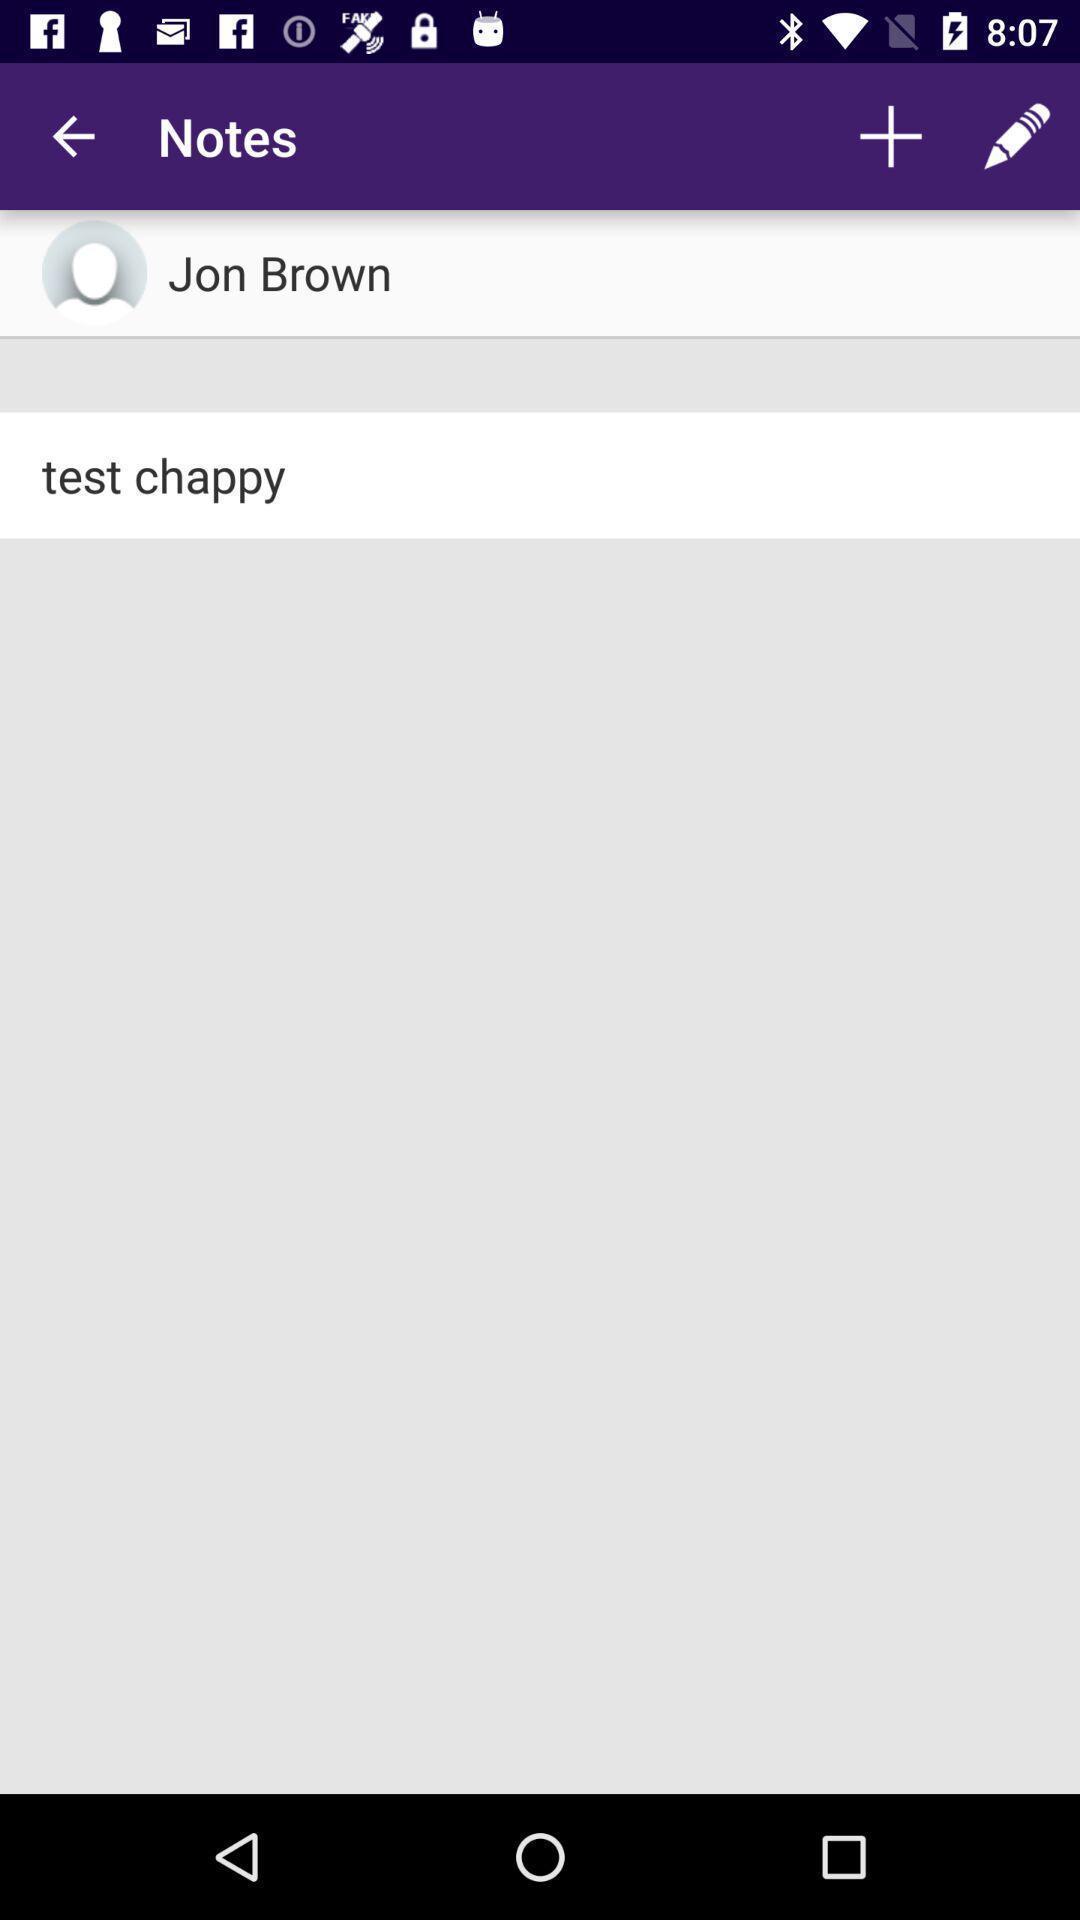Describe the key features of this screenshot. Screen shows notes of a person. 